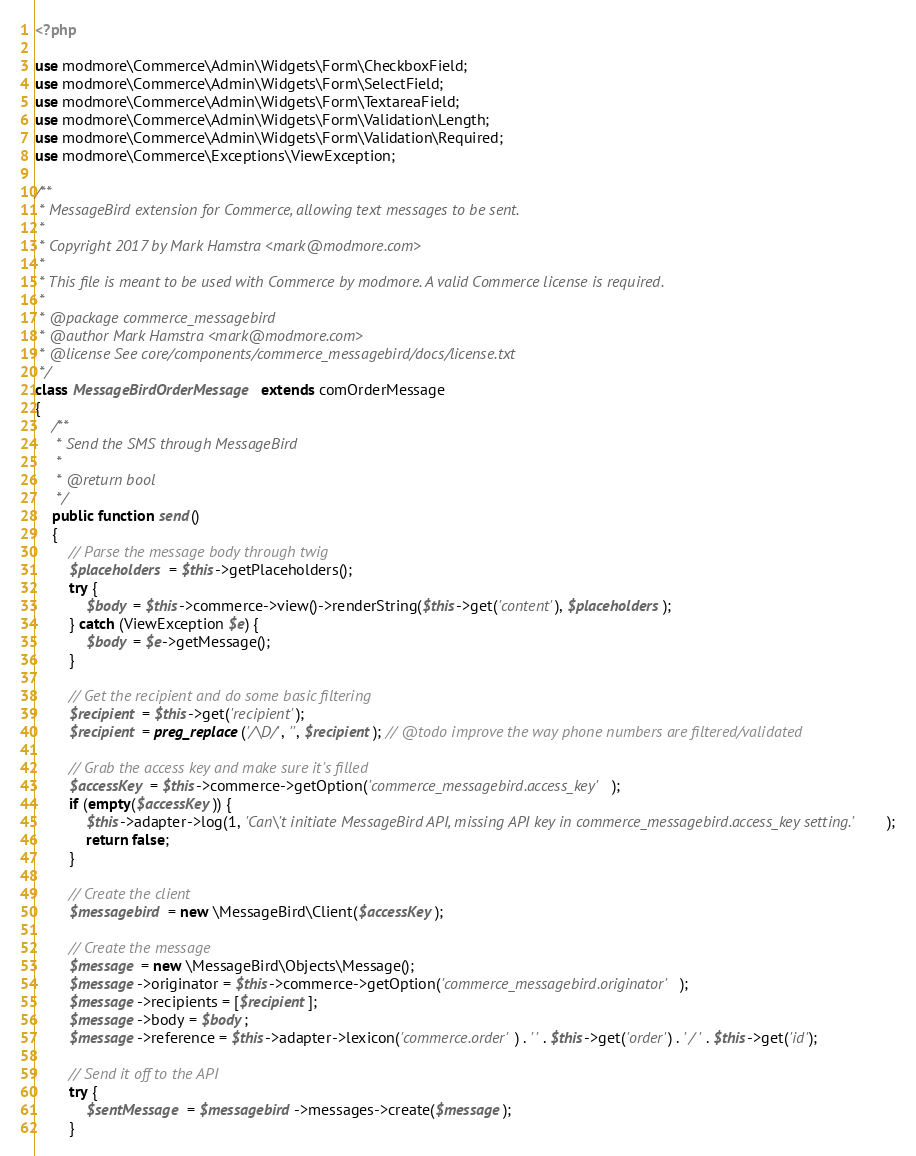Convert code to text. <code><loc_0><loc_0><loc_500><loc_500><_PHP_><?php

use modmore\Commerce\Admin\Widgets\Form\CheckboxField;
use modmore\Commerce\Admin\Widgets\Form\SelectField;
use modmore\Commerce\Admin\Widgets\Form\TextareaField;
use modmore\Commerce\Admin\Widgets\Form\Validation\Length;
use modmore\Commerce\Admin\Widgets\Form\Validation\Required;
use modmore\Commerce\Exceptions\ViewException;

/**
 * MessageBird extension for Commerce, allowing text messages to be sent.
 *
 * Copyright 2017 by Mark Hamstra <mark@modmore.com>
 *
 * This file is meant to be used with Commerce by modmore. A valid Commerce license is required.
 *
 * @package commerce_messagebird
 * @author Mark Hamstra <mark@modmore.com>
 * @license See core/components/commerce_messagebird/docs/license.txt
 */
class MessageBirdOrderMessage extends comOrderMessage
{
    /**
     * Send the SMS through MessageBird
     *
     * @return bool
     */
    public function send()
    {
        // Parse the message body through twig
        $placeholders = $this->getPlaceholders();
        try {
            $body = $this->commerce->view()->renderString($this->get('content'), $placeholders);
        } catch (ViewException $e) {
            $body = $e->getMessage();
        }

        // Get the recipient and do some basic filtering
        $recipient = $this->get('recipient');
        $recipient = preg_replace('/\D/', '', $recipient); // @todo improve the way phone numbers are filtered/validated

        // Grab the access key and make sure it's filled
        $accessKey = $this->commerce->getOption('commerce_messagebird.access_key');
        if (empty($accessKey)) {
            $this->adapter->log(1, 'Can\'t initiate MessageBird API, missing API key in commerce_messagebird.access_key setting.');
            return false;
        }

        // Create the client
        $messagebird = new \MessageBird\Client($accessKey);

        // Create the message
        $message = new \MessageBird\Objects\Message();
        $message->originator = $this->commerce->getOption('commerce_messagebird.originator');
        $message->recipients = [$recipient];
        $message->body = $body;
        $message->reference = $this->adapter->lexicon('commerce.order') . ' ' . $this->get('order') . ' / ' . $this->get('id');

        // Send it off to the API
        try {
            $sentMessage = $messagebird->messages->create($message);
        }</code> 